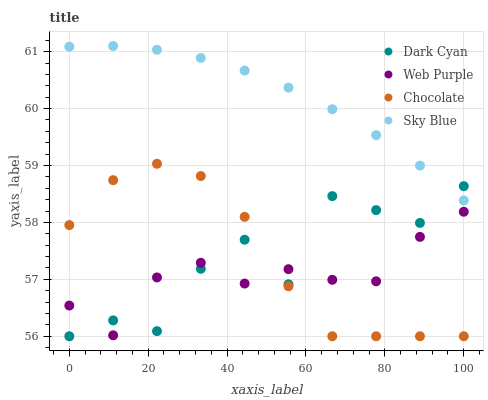Does Web Purple have the minimum area under the curve?
Answer yes or no. Yes. Does Sky Blue have the maximum area under the curve?
Answer yes or no. Yes. Does Sky Blue have the minimum area under the curve?
Answer yes or no. No. Does Web Purple have the maximum area under the curve?
Answer yes or no. No. Is Sky Blue the smoothest?
Answer yes or no. Yes. Is Dark Cyan the roughest?
Answer yes or no. Yes. Is Web Purple the smoothest?
Answer yes or no. No. Is Web Purple the roughest?
Answer yes or no. No. Does Dark Cyan have the lowest value?
Answer yes or no. Yes. Does Web Purple have the lowest value?
Answer yes or no. No. Does Sky Blue have the highest value?
Answer yes or no. Yes. Does Web Purple have the highest value?
Answer yes or no. No. Is Web Purple less than Sky Blue?
Answer yes or no. Yes. Is Sky Blue greater than Web Purple?
Answer yes or no. Yes. Does Chocolate intersect Dark Cyan?
Answer yes or no. Yes. Is Chocolate less than Dark Cyan?
Answer yes or no. No. Is Chocolate greater than Dark Cyan?
Answer yes or no. No. Does Web Purple intersect Sky Blue?
Answer yes or no. No. 